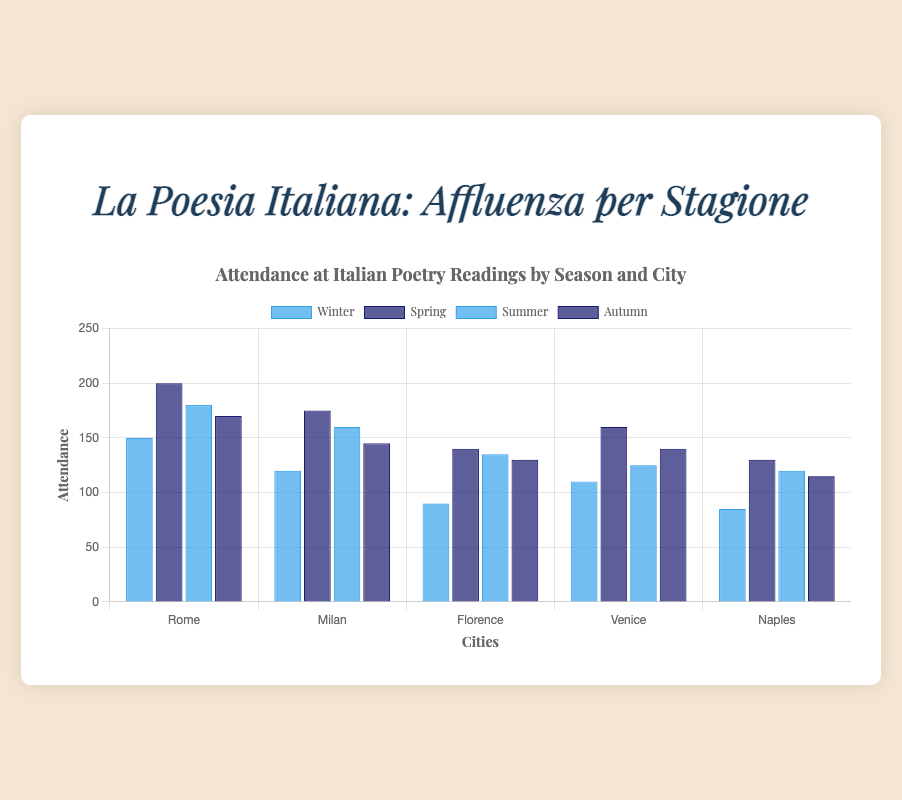Which city has the highest attendance in Spring? In Spring, the highest attendance bar is associated with Rome.
Answer: Rome What is the average attendance in Florence across all seasons? The attendance in Florence is 90 (Winter) + 140 (Spring) + 135 (Summer) + 130 (Autumn) = 495. Dividing by 4 seasons gives 495 / 4 = 123.75.
Answer: 123.75 Which season shows the lowest attendance in Naples? Identifying the lowest height bar for Naples, which is in Winter with 85 attendees.
Answer: Winter How does the attendance in Venice in Winter compare to that in Summer? The height of the bar for Venice in Winter is 110, whereas in Summer it is 125. Therefore, Winter's attendance is less than Summer by 125 - 110 = 15.
Answer: 15 less Which season has the highest total attendance across all cities? Summing for each season: Winter (555), Spring (805), Summer (720), Autumn (700). Spring has the highest total with 805 attendees.
Answer: Spring Is the variance in attendance in Milan higher in Winter or Autumn? Winter attendance in Milan is 120 compared to Autumn's 145. The variance between these is calculated. Milan's variance demonstrated broader changes in attendance during Autumn.
Answer: Autumn What is the total attendance in Rome during Winter and Summer? Rome's Winter attendance is 150 and Summer's is 180. Summing these we get 150 + 180 = 330.
Answer: 330 Compare the difference in attendance between Spring and Autumn in Florence. Attendance in Spring (Florence) is 140, and in Autumn, it's 130. Therefore, the difference is 140 - 130 = 10.
Answer: 10 In which season is the difference in attendance between Milan and Naples the smallest? In Winter, Milan (120) - Naples (85) = 35; Spring, Milan (175) - Naples (130) = 45; Summer, Milan (160) - Naples (120) = 40; Autumn, Milan (145) - Naples (115) = 30, thus Autumn has the smallest difference.
Answer: Autumn Which season has the least variance in attendance across the locations? Winter range: 150 - 85 = 65; Spring range: 200 - 130 = 70; Summer range: 180 - 120 = 60; Autumn range: 170 - 115 = 55. The smallest variance is in Autumn.
Answer: Autumn 